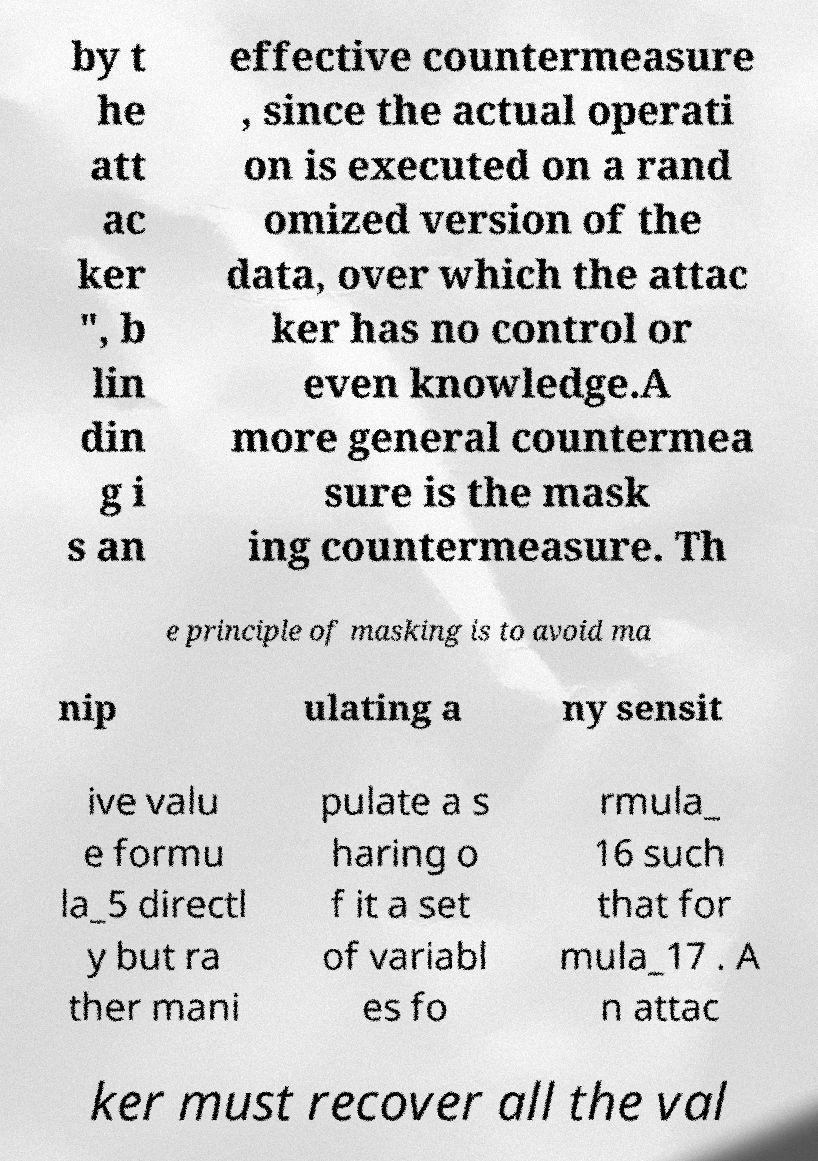I need the written content from this picture converted into text. Can you do that? by t he att ac ker ", b lin din g i s an effective countermeasure , since the actual operati on is executed on a rand omized version of the data, over which the attac ker has no control or even knowledge.A more general countermea sure is the mask ing countermeasure. Th e principle of masking is to avoid ma nip ulating a ny sensit ive valu e formu la_5 directl y but ra ther mani pulate a s haring o f it a set of variabl es fo rmula_ 16 such that for mula_17 . A n attac ker must recover all the val 